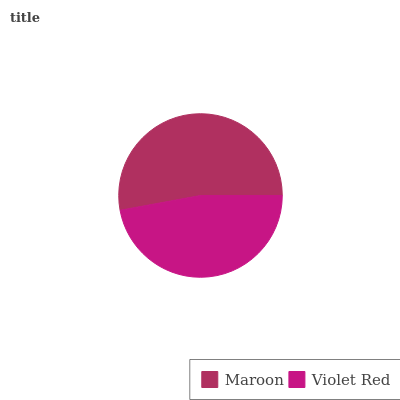Is Violet Red the minimum?
Answer yes or no. Yes. Is Maroon the maximum?
Answer yes or no. Yes. Is Violet Red the maximum?
Answer yes or no. No. Is Maroon greater than Violet Red?
Answer yes or no. Yes. Is Violet Red less than Maroon?
Answer yes or no. Yes. Is Violet Red greater than Maroon?
Answer yes or no. No. Is Maroon less than Violet Red?
Answer yes or no. No. Is Maroon the high median?
Answer yes or no. Yes. Is Violet Red the low median?
Answer yes or no. Yes. Is Violet Red the high median?
Answer yes or no. No. Is Maroon the low median?
Answer yes or no. No. 